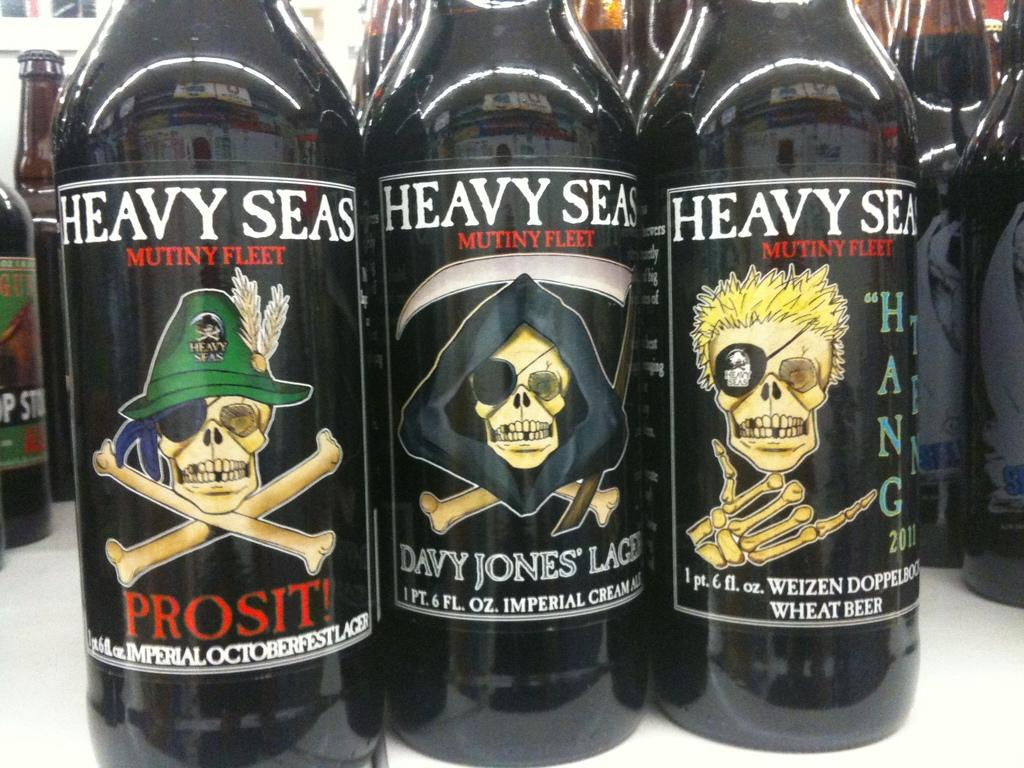<image>
Write a terse but informative summary of the picture. bottles of heavy seas mutiny fleet standing next to each other 